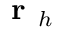<formula> <loc_0><loc_0><loc_500><loc_500>r _ { h }</formula> 